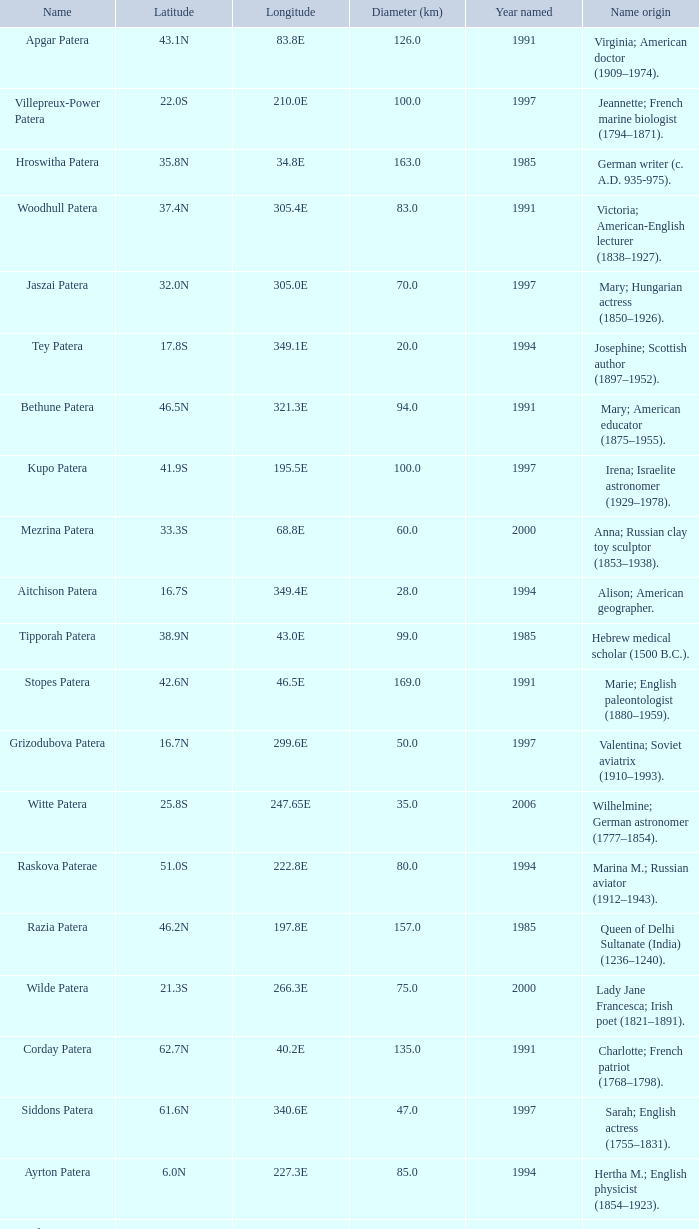What is the origin of the name of Keller Patera?  Helen; blind and deaf American writer (1880–1968). 